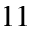Convert formula to latex. <formula><loc_0><loc_0><loc_500><loc_500>1 1</formula> 